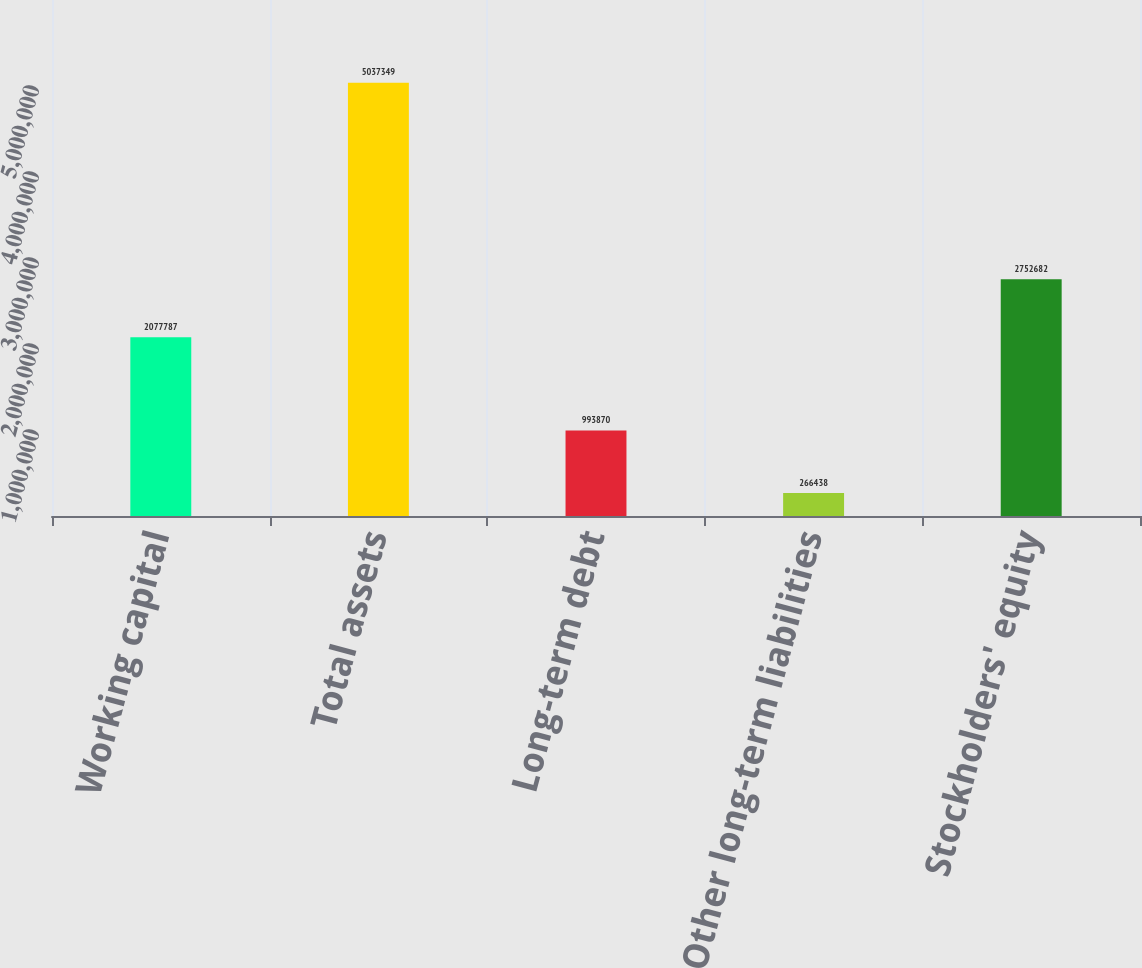<chart> <loc_0><loc_0><loc_500><loc_500><bar_chart><fcel>Working capital<fcel>Total assets<fcel>Long-term debt<fcel>Other long-term liabilities<fcel>Stockholders' equity<nl><fcel>2.07779e+06<fcel>5.03735e+06<fcel>993870<fcel>266438<fcel>2.75268e+06<nl></chart> 